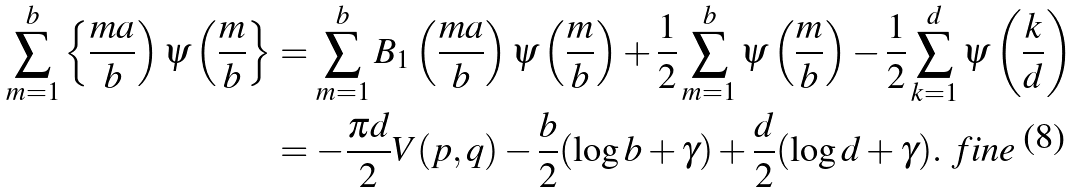Convert formula to latex. <formula><loc_0><loc_0><loc_500><loc_500>\sum _ { m = 1 } ^ { b } \left \{ \frac { m a } { b } \right ) \psi \left ( \frac { m } { b } \right \} & = \sum _ { m = 1 } ^ { b } B _ { 1 } \left ( \frac { m a } { b } \right ) \psi \left ( \frac { m } { b } \right ) + \frac { 1 } { 2 } \sum _ { m = 1 } ^ { b } \psi \left ( \frac { m } { b } \right ) - \frac { 1 } { 2 } \sum _ { k = 1 } ^ { d } \psi \left ( \frac { k } { d } \right ) \\ & = - \frac { \pi d } { 2 } V ( p , q ) - \frac { b } { 2 } ( \log b + \gamma ) + \frac { d } { 2 } ( \log d + \gamma ) . \ f i n e</formula> 